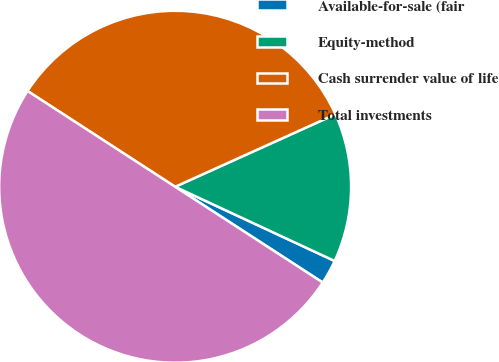<chart> <loc_0><loc_0><loc_500><loc_500><pie_chart><fcel>Available-for-sale (fair<fcel>Equity-method<fcel>Cash surrender value of life<fcel>Total investments<nl><fcel>2.23%<fcel>13.69%<fcel>34.08%<fcel>50.0%<nl></chart> 